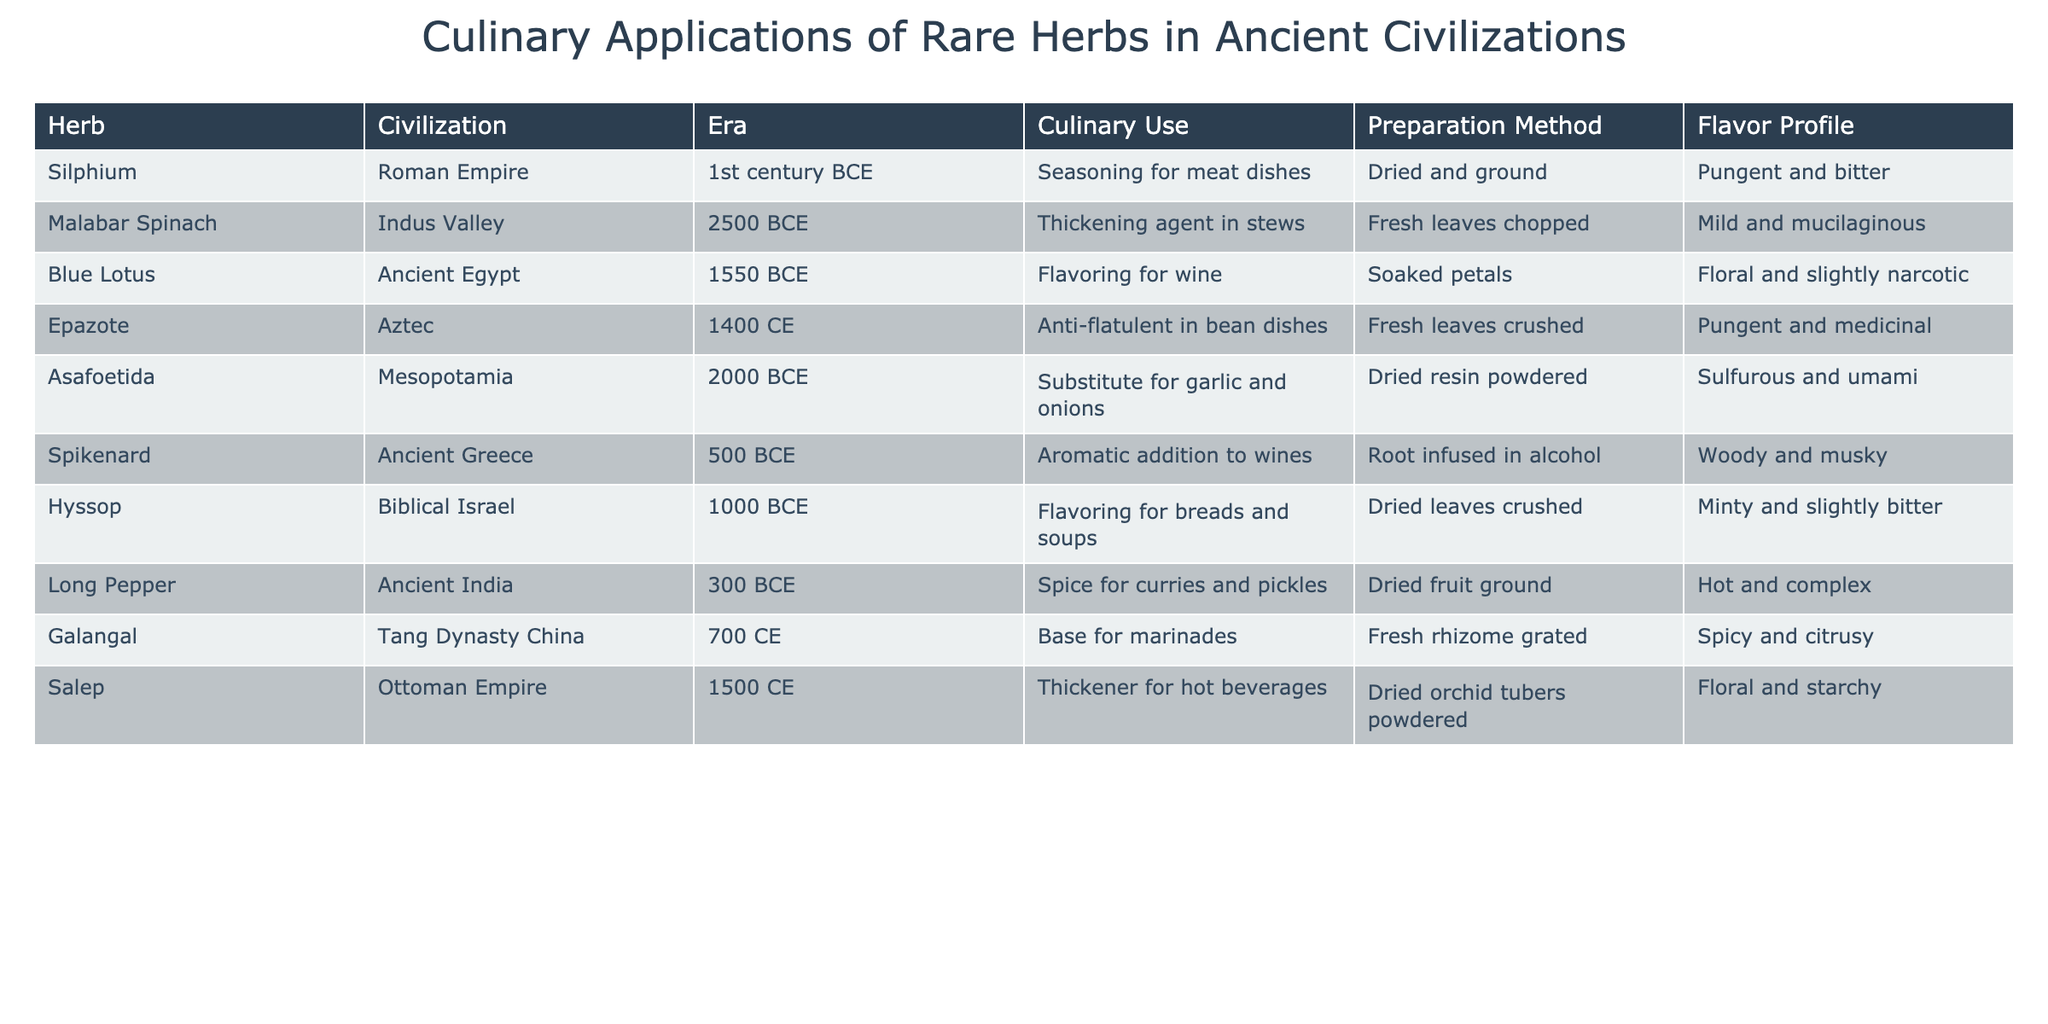What culinary use is associated with Silphium in the Roman Empire? The table shows that Silphium was used as a seasoning for meat dishes in the Roman Empire.
Answer: Seasoning for meat dishes Which preparation method is used for the Malabar Spinach? According to the table, Malabar Spinach is prepared by chopping fresh leaves.
Answer: Fresh leaves chopped Which herb was used as a substitute for garlic and onions in Mesopotamia? The table indicates that Asafoetida served as a substitute for garlic and onions in Mesopotamia.
Answer: Asafoetida What flavor profile is attributed to Epazote? The table states that Epazote has a pungent and medicinal flavor profile.
Answer: Pungent and medicinal Which civilization used Galangal, and what was its culinary application? The table shows that Galangal was used in Tang Dynasty China as a base for marinades.
Answer: Tang Dynasty China; Base for marinades How many herbs listed were used in ancient Greece, and what were their uses? The table lists one herb used in ancient Greece—Spikenard, which was an aromatic addition to wines.
Answer: One; Aromatic addition to wines Is Salep used as a thickener for hot beverages? Referring to the table, Salep is indeed noted as a thickener for hot beverages.
Answer: Yes What is the common flavor profile between Hyssop and Long Pepper? The table indicates that Hyssop has a minty and slightly bitter profile, while Long Pepper has a hot and complex profile; they are distinct in flavor.
Answer: No, they have distinct profiles How does the culinary use of Blue Lotus relate to its preparation method? The table shows Blue Lotus used for flavoring wine, prepared by soaking petals, which enhances the floral aspect of the drink.
Answer: Both enhance the floral quality Which herb has a culinary use that specifically targets digestion, and what is that use? According to the table, Epazote is noted for its anti-flatulent properties in bean dishes.
Answer: Epazote; Anti-flatulent in bean dishes 